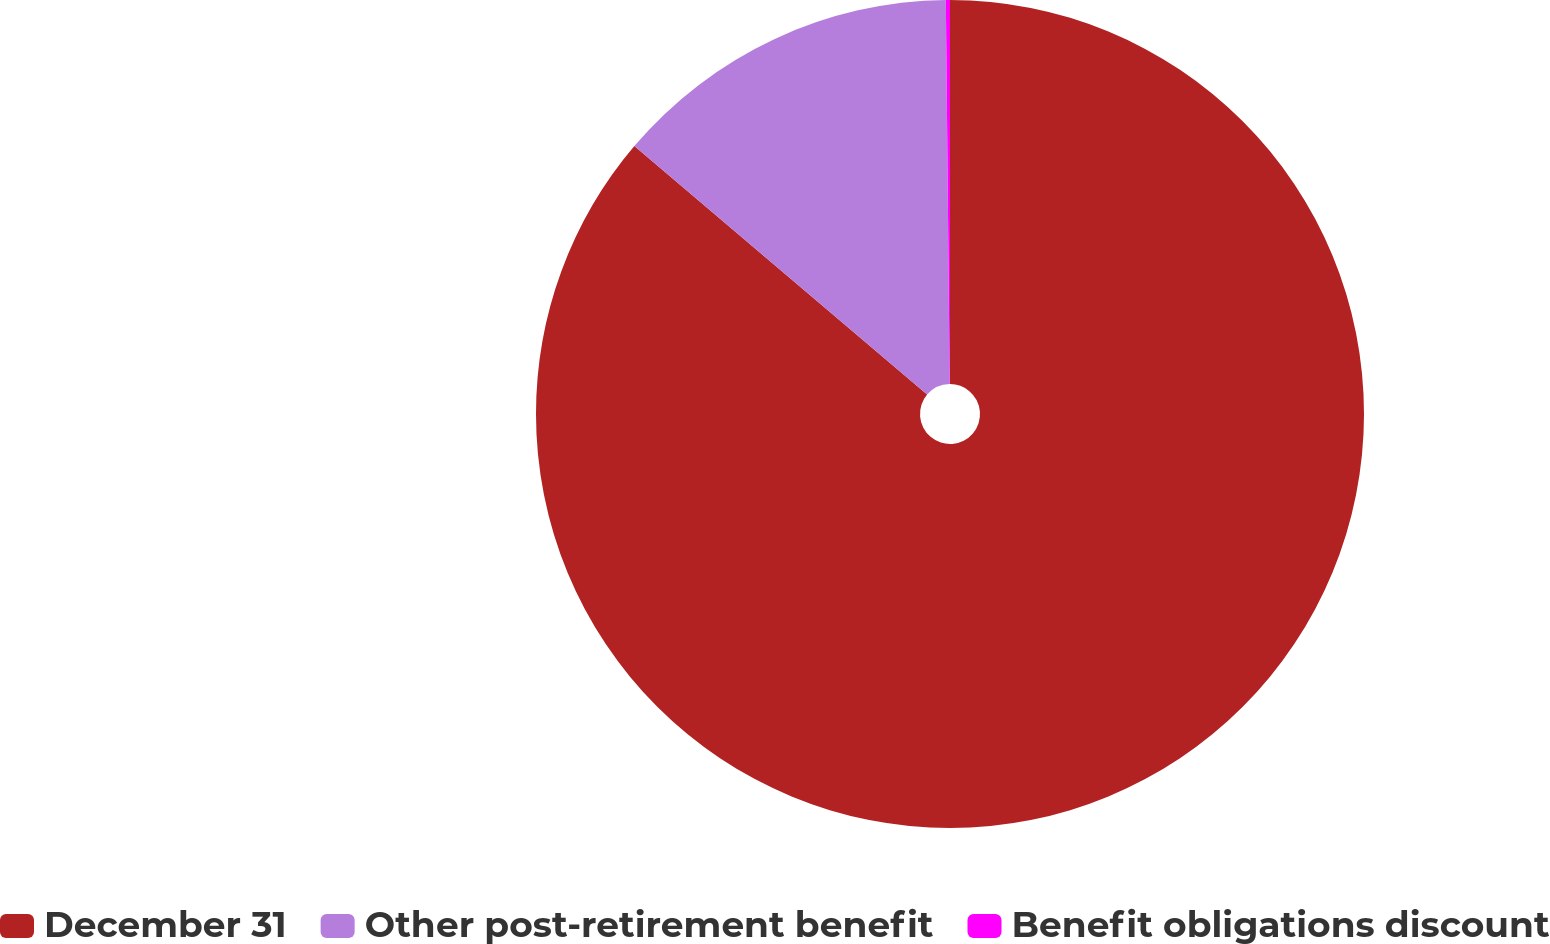Convert chart. <chart><loc_0><loc_0><loc_500><loc_500><pie_chart><fcel>December 31<fcel>Other post-retirement benefit<fcel>Benefit obligations discount<nl><fcel>86.2%<fcel>13.64%<fcel>0.16%<nl></chart> 